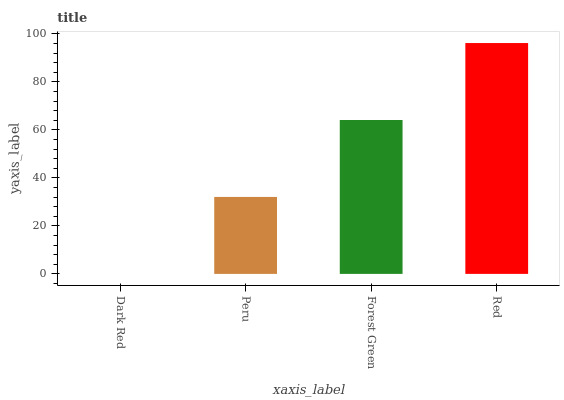Is Dark Red the minimum?
Answer yes or no. Yes. Is Red the maximum?
Answer yes or no. Yes. Is Peru the minimum?
Answer yes or no. No. Is Peru the maximum?
Answer yes or no. No. Is Peru greater than Dark Red?
Answer yes or no. Yes. Is Dark Red less than Peru?
Answer yes or no. Yes. Is Dark Red greater than Peru?
Answer yes or no. No. Is Peru less than Dark Red?
Answer yes or no. No. Is Forest Green the high median?
Answer yes or no. Yes. Is Peru the low median?
Answer yes or no. Yes. Is Peru the high median?
Answer yes or no. No. Is Red the low median?
Answer yes or no. No. 